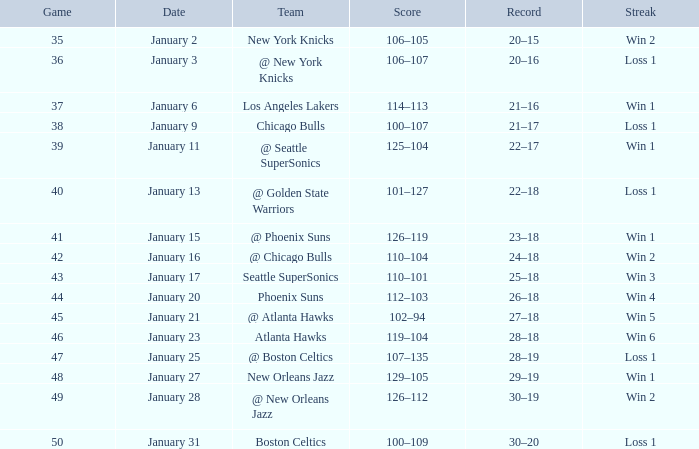In a game with a 20-16 record, what constitutes the streak? Loss 1. 